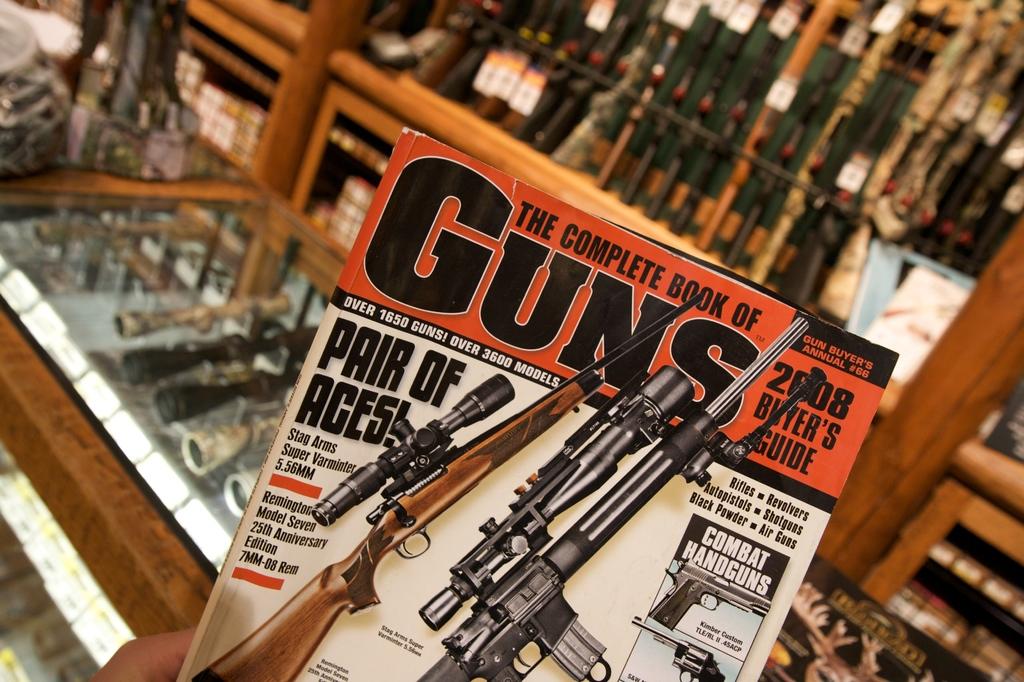This is the complete book of what?
Provide a succinct answer. Guns. 